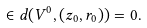Convert formula to latex. <formula><loc_0><loc_0><loc_500><loc_500>\in d ( V ^ { 0 } , ( z _ { 0 } , r _ { 0 } ) ) = 0 .</formula> 